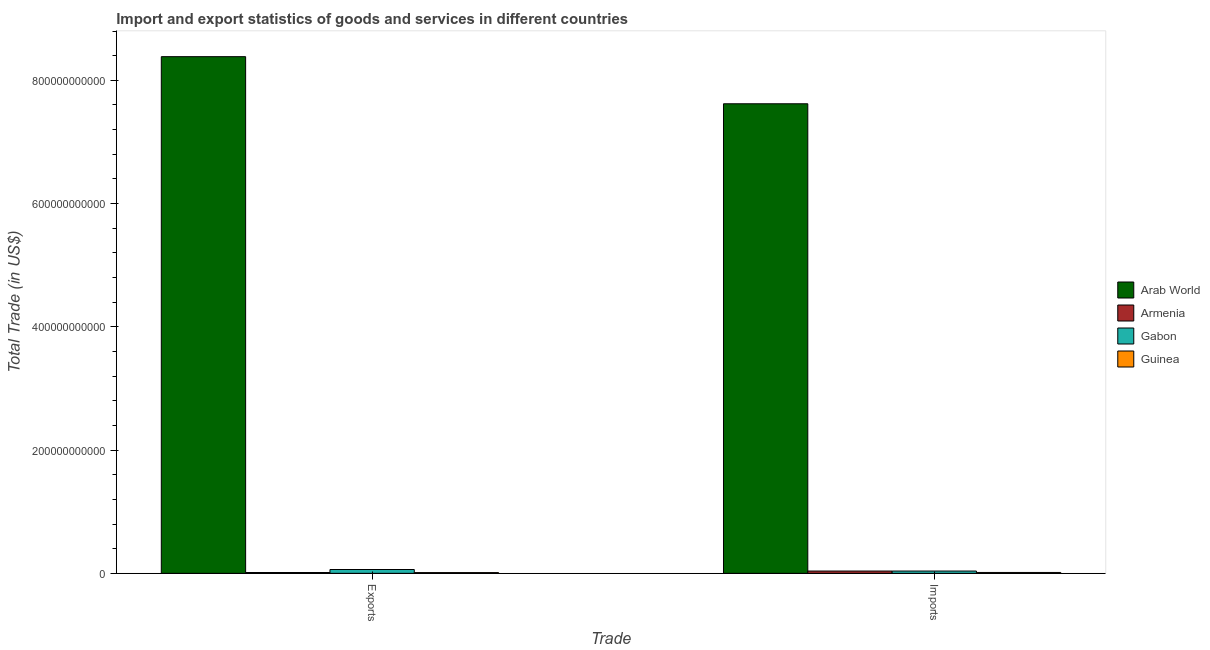How many different coloured bars are there?
Make the answer very short. 4. Are the number of bars per tick equal to the number of legend labels?
Provide a succinct answer. Yes. How many bars are there on the 1st tick from the left?
Provide a succinct answer. 4. What is the label of the 2nd group of bars from the left?
Keep it short and to the point. Imports. What is the export of goods and services in Arab World?
Your response must be concise. 8.38e+11. Across all countries, what is the maximum export of goods and services?
Give a very brief answer. 8.38e+11. Across all countries, what is the minimum imports of goods and services?
Make the answer very short. 1.42e+09. In which country was the imports of goods and services maximum?
Give a very brief answer. Arab World. In which country was the imports of goods and services minimum?
Give a very brief answer. Guinea. What is the total export of goods and services in the graph?
Provide a short and direct response. 8.47e+11. What is the difference between the export of goods and services in Gabon and that in Armenia?
Provide a succinct answer. 4.86e+09. What is the difference between the imports of goods and services in Gabon and the export of goods and services in Armenia?
Your response must be concise. 2.39e+09. What is the average export of goods and services per country?
Provide a short and direct response. 2.12e+11. What is the difference between the export of goods and services and imports of goods and services in Guinea?
Provide a succinct answer. -1.96e+08. In how many countries, is the export of goods and services greater than 640000000000 US$?
Your answer should be compact. 1. What is the ratio of the imports of goods and services in Armenia to that in Gabon?
Offer a terse response. 1. Is the export of goods and services in Arab World less than that in Armenia?
Your response must be concise. No. In how many countries, is the imports of goods and services greater than the average imports of goods and services taken over all countries?
Ensure brevity in your answer.  1. What does the 3rd bar from the left in Exports represents?
Ensure brevity in your answer.  Gabon. What does the 2nd bar from the right in Exports represents?
Your response must be concise. Gabon. How many bars are there?
Ensure brevity in your answer.  8. How many countries are there in the graph?
Your response must be concise. 4. What is the difference between two consecutive major ticks on the Y-axis?
Ensure brevity in your answer.  2.00e+11. Does the graph contain grids?
Your answer should be very brief. No. How many legend labels are there?
Provide a succinct answer. 4. What is the title of the graph?
Offer a very short reply. Import and export statistics of goods and services in different countries. What is the label or title of the X-axis?
Ensure brevity in your answer.  Trade. What is the label or title of the Y-axis?
Keep it short and to the point. Total Trade (in US$). What is the Total Trade (in US$) of Arab World in Exports?
Make the answer very short. 8.38e+11. What is the Total Trade (in US$) of Armenia in Exports?
Ensure brevity in your answer.  1.34e+09. What is the Total Trade (in US$) of Gabon in Exports?
Provide a succinct answer. 6.20e+09. What is the Total Trade (in US$) of Guinea in Exports?
Make the answer very short. 1.22e+09. What is the Total Trade (in US$) of Arab World in Imports?
Your answer should be very brief. 7.62e+11. What is the Total Trade (in US$) in Armenia in Imports?
Provide a succinct answer. 3.72e+09. What is the Total Trade (in US$) of Gabon in Imports?
Offer a very short reply. 3.73e+09. What is the Total Trade (in US$) in Guinea in Imports?
Keep it short and to the point. 1.42e+09. Across all Trade, what is the maximum Total Trade (in US$) of Arab World?
Provide a short and direct response. 8.38e+11. Across all Trade, what is the maximum Total Trade (in US$) in Armenia?
Keep it short and to the point. 3.72e+09. Across all Trade, what is the maximum Total Trade (in US$) of Gabon?
Offer a terse response. 6.20e+09. Across all Trade, what is the maximum Total Trade (in US$) of Guinea?
Provide a succinct answer. 1.42e+09. Across all Trade, what is the minimum Total Trade (in US$) in Arab World?
Provide a succinct answer. 7.62e+11. Across all Trade, what is the minimum Total Trade (in US$) in Armenia?
Keep it short and to the point. 1.34e+09. Across all Trade, what is the minimum Total Trade (in US$) in Gabon?
Keep it short and to the point. 3.73e+09. Across all Trade, what is the minimum Total Trade (in US$) in Guinea?
Make the answer very short. 1.22e+09. What is the total Total Trade (in US$) in Arab World in the graph?
Your answer should be very brief. 1.60e+12. What is the total Total Trade (in US$) of Armenia in the graph?
Provide a succinct answer. 5.06e+09. What is the total Total Trade (in US$) of Gabon in the graph?
Offer a very short reply. 9.93e+09. What is the total Total Trade (in US$) in Guinea in the graph?
Offer a very short reply. 2.64e+09. What is the difference between the Total Trade (in US$) of Arab World in Exports and that in Imports?
Make the answer very short. 7.65e+1. What is the difference between the Total Trade (in US$) of Armenia in Exports and that in Imports?
Provide a short and direct response. -2.38e+09. What is the difference between the Total Trade (in US$) of Gabon in Exports and that in Imports?
Offer a very short reply. 2.47e+09. What is the difference between the Total Trade (in US$) of Guinea in Exports and that in Imports?
Offer a terse response. -1.96e+08. What is the difference between the Total Trade (in US$) of Arab World in Exports and the Total Trade (in US$) of Armenia in Imports?
Ensure brevity in your answer.  8.35e+11. What is the difference between the Total Trade (in US$) of Arab World in Exports and the Total Trade (in US$) of Gabon in Imports?
Ensure brevity in your answer.  8.35e+11. What is the difference between the Total Trade (in US$) in Arab World in Exports and the Total Trade (in US$) in Guinea in Imports?
Make the answer very short. 8.37e+11. What is the difference between the Total Trade (in US$) in Armenia in Exports and the Total Trade (in US$) in Gabon in Imports?
Give a very brief answer. -2.39e+09. What is the difference between the Total Trade (in US$) in Armenia in Exports and the Total Trade (in US$) in Guinea in Imports?
Ensure brevity in your answer.  -8.13e+07. What is the difference between the Total Trade (in US$) in Gabon in Exports and the Total Trade (in US$) in Guinea in Imports?
Ensure brevity in your answer.  4.78e+09. What is the average Total Trade (in US$) of Arab World per Trade?
Offer a terse response. 8.00e+11. What is the average Total Trade (in US$) in Armenia per Trade?
Ensure brevity in your answer.  2.53e+09. What is the average Total Trade (in US$) of Gabon per Trade?
Your answer should be very brief. 4.96e+09. What is the average Total Trade (in US$) of Guinea per Trade?
Make the answer very short. 1.32e+09. What is the difference between the Total Trade (in US$) in Arab World and Total Trade (in US$) in Armenia in Exports?
Offer a very short reply. 8.37e+11. What is the difference between the Total Trade (in US$) in Arab World and Total Trade (in US$) in Gabon in Exports?
Provide a short and direct response. 8.32e+11. What is the difference between the Total Trade (in US$) of Arab World and Total Trade (in US$) of Guinea in Exports?
Provide a succinct answer. 8.37e+11. What is the difference between the Total Trade (in US$) of Armenia and Total Trade (in US$) of Gabon in Exports?
Give a very brief answer. -4.86e+09. What is the difference between the Total Trade (in US$) in Armenia and Total Trade (in US$) in Guinea in Exports?
Your response must be concise. 1.15e+08. What is the difference between the Total Trade (in US$) in Gabon and Total Trade (in US$) in Guinea in Exports?
Offer a terse response. 4.98e+09. What is the difference between the Total Trade (in US$) in Arab World and Total Trade (in US$) in Armenia in Imports?
Make the answer very short. 7.58e+11. What is the difference between the Total Trade (in US$) in Arab World and Total Trade (in US$) in Gabon in Imports?
Your response must be concise. 7.58e+11. What is the difference between the Total Trade (in US$) in Arab World and Total Trade (in US$) in Guinea in Imports?
Keep it short and to the point. 7.61e+11. What is the difference between the Total Trade (in US$) in Armenia and Total Trade (in US$) in Gabon in Imports?
Provide a short and direct response. -9.26e+06. What is the difference between the Total Trade (in US$) in Armenia and Total Trade (in US$) in Guinea in Imports?
Provide a short and direct response. 2.30e+09. What is the difference between the Total Trade (in US$) of Gabon and Total Trade (in US$) of Guinea in Imports?
Provide a succinct answer. 2.31e+09. What is the ratio of the Total Trade (in US$) in Arab World in Exports to that in Imports?
Your response must be concise. 1.1. What is the ratio of the Total Trade (in US$) of Armenia in Exports to that in Imports?
Provide a short and direct response. 0.36. What is the ratio of the Total Trade (in US$) in Gabon in Exports to that in Imports?
Make the answer very short. 1.66. What is the ratio of the Total Trade (in US$) of Guinea in Exports to that in Imports?
Keep it short and to the point. 0.86. What is the difference between the highest and the second highest Total Trade (in US$) of Arab World?
Your response must be concise. 7.65e+1. What is the difference between the highest and the second highest Total Trade (in US$) in Armenia?
Your response must be concise. 2.38e+09. What is the difference between the highest and the second highest Total Trade (in US$) of Gabon?
Ensure brevity in your answer.  2.47e+09. What is the difference between the highest and the second highest Total Trade (in US$) in Guinea?
Make the answer very short. 1.96e+08. What is the difference between the highest and the lowest Total Trade (in US$) in Arab World?
Your answer should be very brief. 7.65e+1. What is the difference between the highest and the lowest Total Trade (in US$) in Armenia?
Provide a short and direct response. 2.38e+09. What is the difference between the highest and the lowest Total Trade (in US$) of Gabon?
Your response must be concise. 2.47e+09. What is the difference between the highest and the lowest Total Trade (in US$) in Guinea?
Offer a terse response. 1.96e+08. 